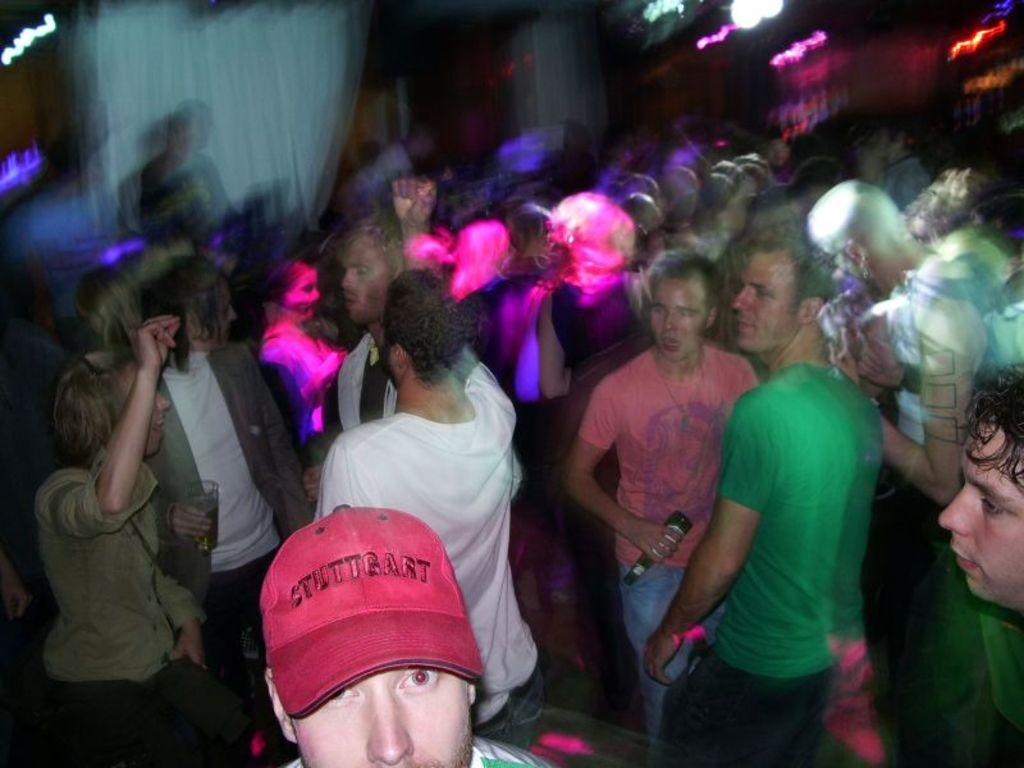How many people are in the image? There are many people in the image. What are the people doing in the image? The people are dancing. Where is the image likely taken? The image appears to be taken inside a pub. What can be seen on the ceiling in the image? There are lights on the ceiling. What is the account number of the pig in the image? There is no pig present in the image, and therefore no account number can be associated with it. 